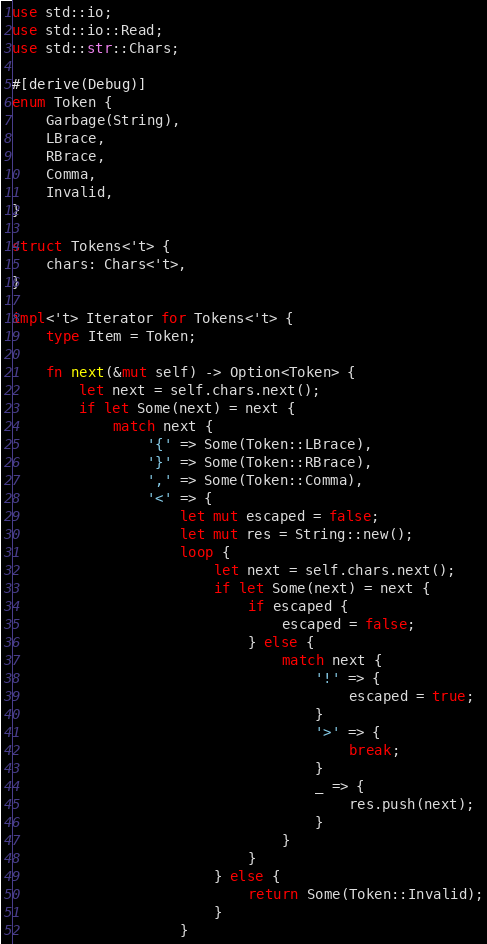Convert code to text. <code><loc_0><loc_0><loc_500><loc_500><_Rust_>use std::io;
use std::io::Read;
use std::str::Chars;

#[derive(Debug)]
enum Token {
    Garbage(String),
    LBrace,
    RBrace,
    Comma,
    Invalid,
}

struct Tokens<'t> {
    chars: Chars<'t>,
}

impl<'t> Iterator for Tokens<'t> {
    type Item = Token;

    fn next(&mut self) -> Option<Token> {
        let next = self.chars.next();
        if let Some(next) = next {
            match next {
                '{' => Some(Token::LBrace),
                '}' => Some(Token::RBrace),
                ',' => Some(Token::Comma),
                '<' => {
                    let mut escaped = false;
                    let mut res = String::new();
                    loop {
                        let next = self.chars.next();
                        if let Some(next) = next {
                            if escaped {
                                escaped = false;
                            } else {
                                match next {
                                    '!' => {
                                        escaped = true;
                                    }
                                    '>' => {
                                        break;
                                    }
                                    _ => {
                                        res.push(next);
                                    }
                                }
                            }
                        } else {
                            return Some(Token::Invalid);
                        }
                    }</code> 